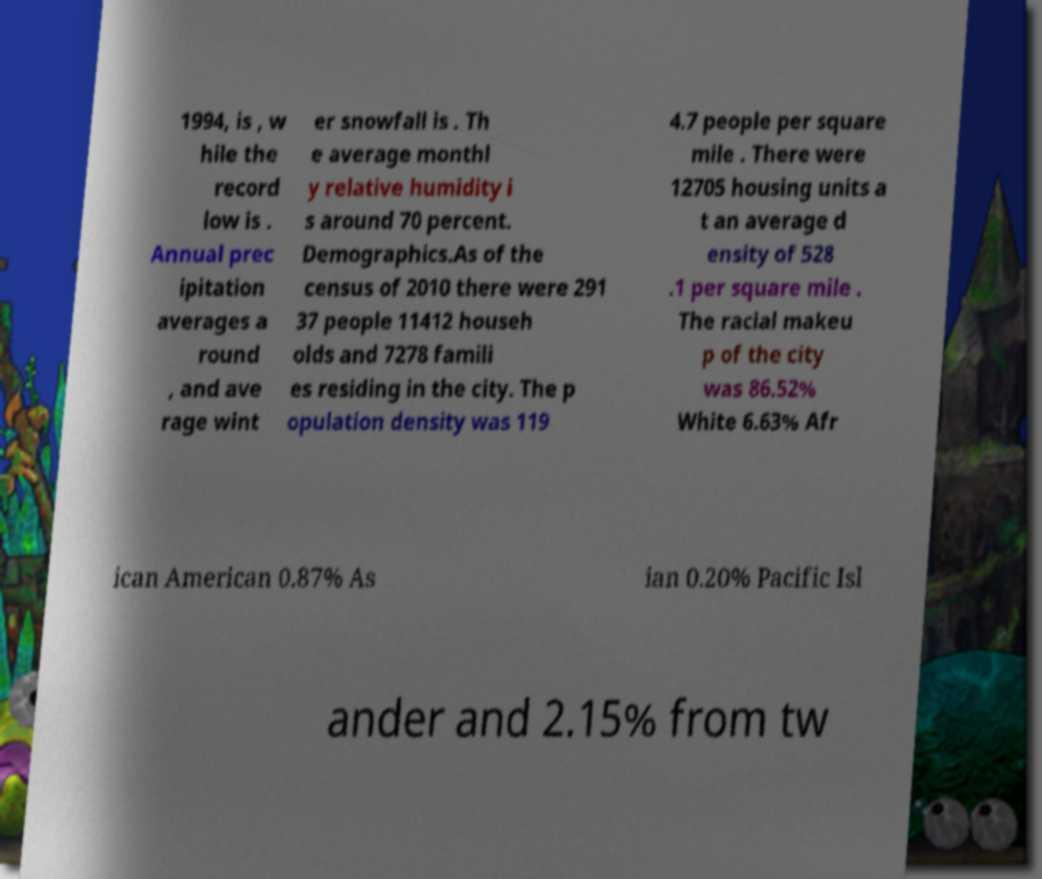Please read and relay the text visible in this image. What does it say? 1994, is , w hile the record low is . Annual prec ipitation averages a round , and ave rage wint er snowfall is . Th e average monthl y relative humidity i s around 70 percent. Demographics.As of the census of 2010 there were 291 37 people 11412 househ olds and 7278 famili es residing in the city. The p opulation density was 119 4.7 people per square mile . There were 12705 housing units a t an average d ensity of 528 .1 per square mile . The racial makeu p of the city was 86.52% White 6.63% Afr ican American 0.87% As ian 0.20% Pacific Isl ander and 2.15% from tw 